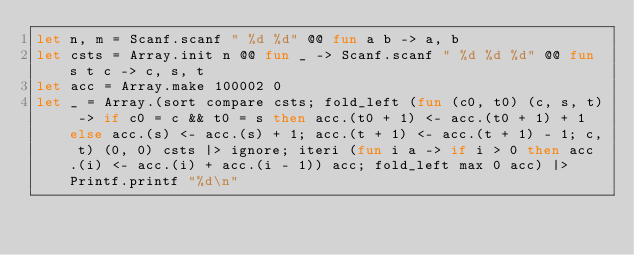<code> <loc_0><loc_0><loc_500><loc_500><_OCaml_>let n, m = Scanf.scanf " %d %d" @@ fun a b -> a, b
let csts = Array.init n @@ fun _ -> Scanf.scanf " %d %d %d" @@ fun s t c -> c, s, t
let acc = Array.make 100002 0
let _ = Array.(sort compare csts; fold_left (fun (c0, t0) (c, s, t) -> if c0 = c && t0 = s then acc.(t0 + 1) <- acc.(t0 + 1) + 1 else acc.(s) <- acc.(s) + 1; acc.(t + 1) <- acc.(t + 1) - 1; c, t) (0, 0) csts |> ignore; iteri (fun i a -> if i > 0 then acc.(i) <- acc.(i) + acc.(i - 1)) acc; fold_left max 0 acc) |> Printf.printf "%d\n"</code> 